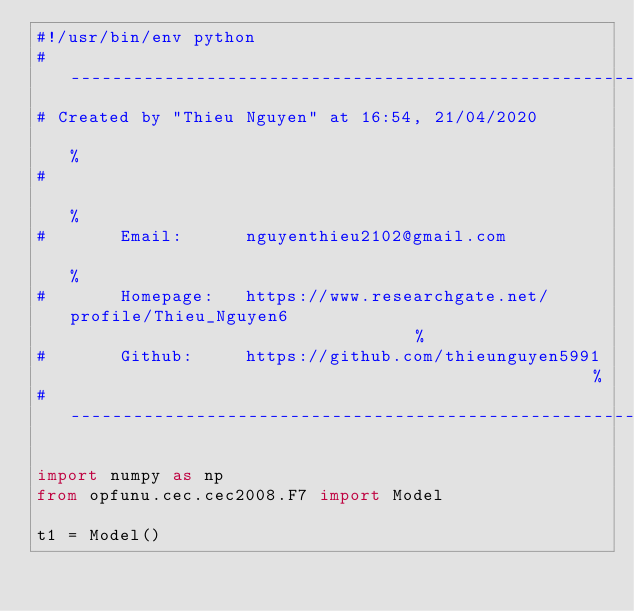Convert code to text. <code><loc_0><loc_0><loc_500><loc_500><_Python_>#!/usr/bin/env python
# ------------------------------------------------------------------------------------------------------%
# Created by "Thieu Nguyen" at 16:54, 21/04/2020                                                        %
#                                                                                                       %
#       Email:      nguyenthieu2102@gmail.com                                                           %
#       Homepage:   https://www.researchgate.net/profile/Thieu_Nguyen6                                  %
#       Github:     https://github.com/thieunguyen5991                                                  %
#-------------------------------------------------------------------------------------------------------%

import numpy as np
from opfunu.cec.cec2008.F7 import Model

t1 = Model()
</code> 